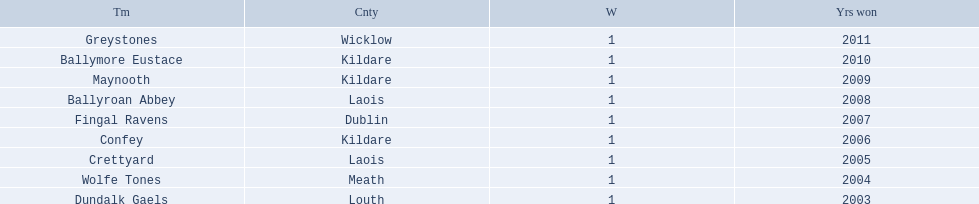What county is the team that won in 2009 from? Kildare. What is the teams name? Maynooth. I'm looking to parse the entire table for insights. Could you assist me with that? {'header': ['Tm', 'Cnty', 'W', 'Yrs won'], 'rows': [['Greystones', 'Wicklow', '1', '2011'], ['Ballymore Eustace', 'Kildare', '1', '2010'], ['Maynooth', 'Kildare', '1', '2009'], ['Ballyroan Abbey', 'Laois', '1', '2008'], ['Fingal Ravens', 'Dublin', '1', '2007'], ['Confey', 'Kildare', '1', '2006'], ['Crettyard', 'Laois', '1', '2005'], ['Wolfe Tones', 'Meath', '1', '2004'], ['Dundalk Gaels', 'Louth', '1', '2003']]} 